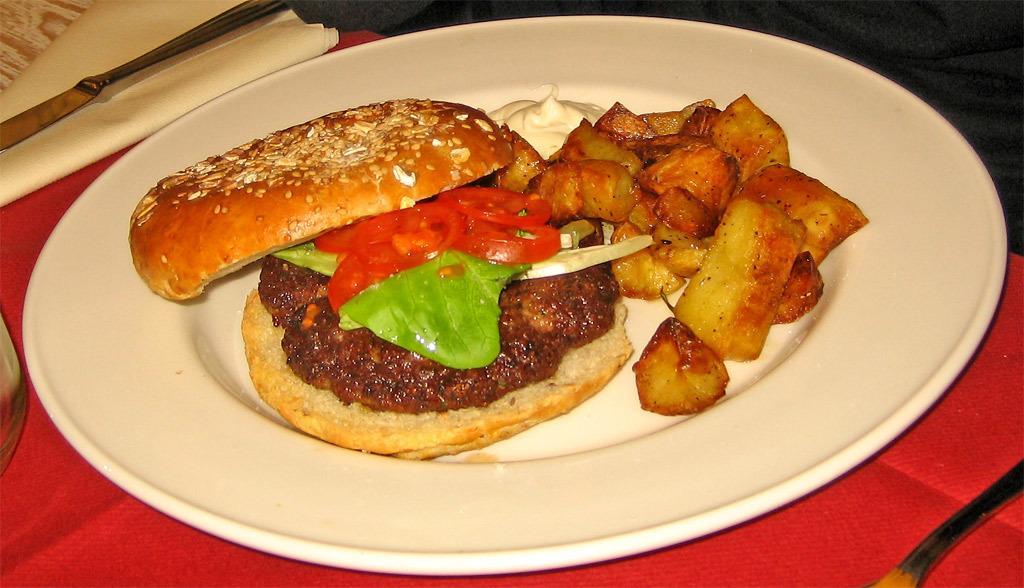Please provide a concise description of this image. In this image we can see some food containing a sandwich, fried potato and cream in a plate which is placed on the table. We can also see a knife and some tissue papers on the table. 